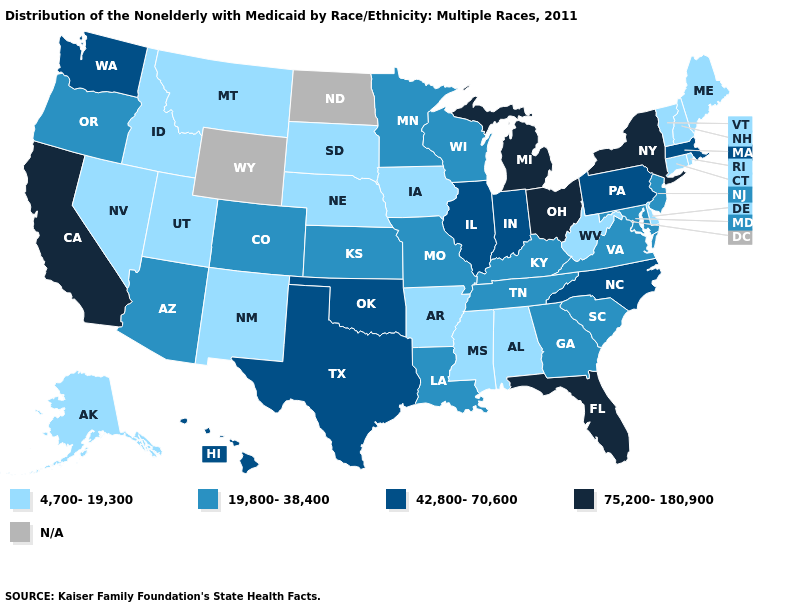Name the states that have a value in the range 75,200-180,900?
Write a very short answer. California, Florida, Michigan, New York, Ohio. Name the states that have a value in the range 19,800-38,400?
Keep it brief. Arizona, Colorado, Georgia, Kansas, Kentucky, Louisiana, Maryland, Minnesota, Missouri, New Jersey, Oregon, South Carolina, Tennessee, Virginia, Wisconsin. Name the states that have a value in the range 4,700-19,300?
Concise answer only. Alabama, Alaska, Arkansas, Connecticut, Delaware, Idaho, Iowa, Maine, Mississippi, Montana, Nebraska, Nevada, New Hampshire, New Mexico, Rhode Island, South Dakota, Utah, Vermont, West Virginia. Among the states that border Rhode Island , does Connecticut have the lowest value?
Give a very brief answer. Yes. Among the states that border Kansas , which have the highest value?
Keep it brief. Oklahoma. Among the states that border New York , does Vermont have the lowest value?
Write a very short answer. Yes. Among the states that border Oregon , does California have the lowest value?
Quick response, please. No. What is the value of Iowa?
Give a very brief answer. 4,700-19,300. What is the value of Pennsylvania?
Answer briefly. 42,800-70,600. Among the states that border Arizona , which have the lowest value?
Concise answer only. Nevada, New Mexico, Utah. What is the value of Colorado?
Quick response, please. 19,800-38,400. Does the map have missing data?
Answer briefly. Yes. What is the value of Kentucky?
Short answer required. 19,800-38,400. 